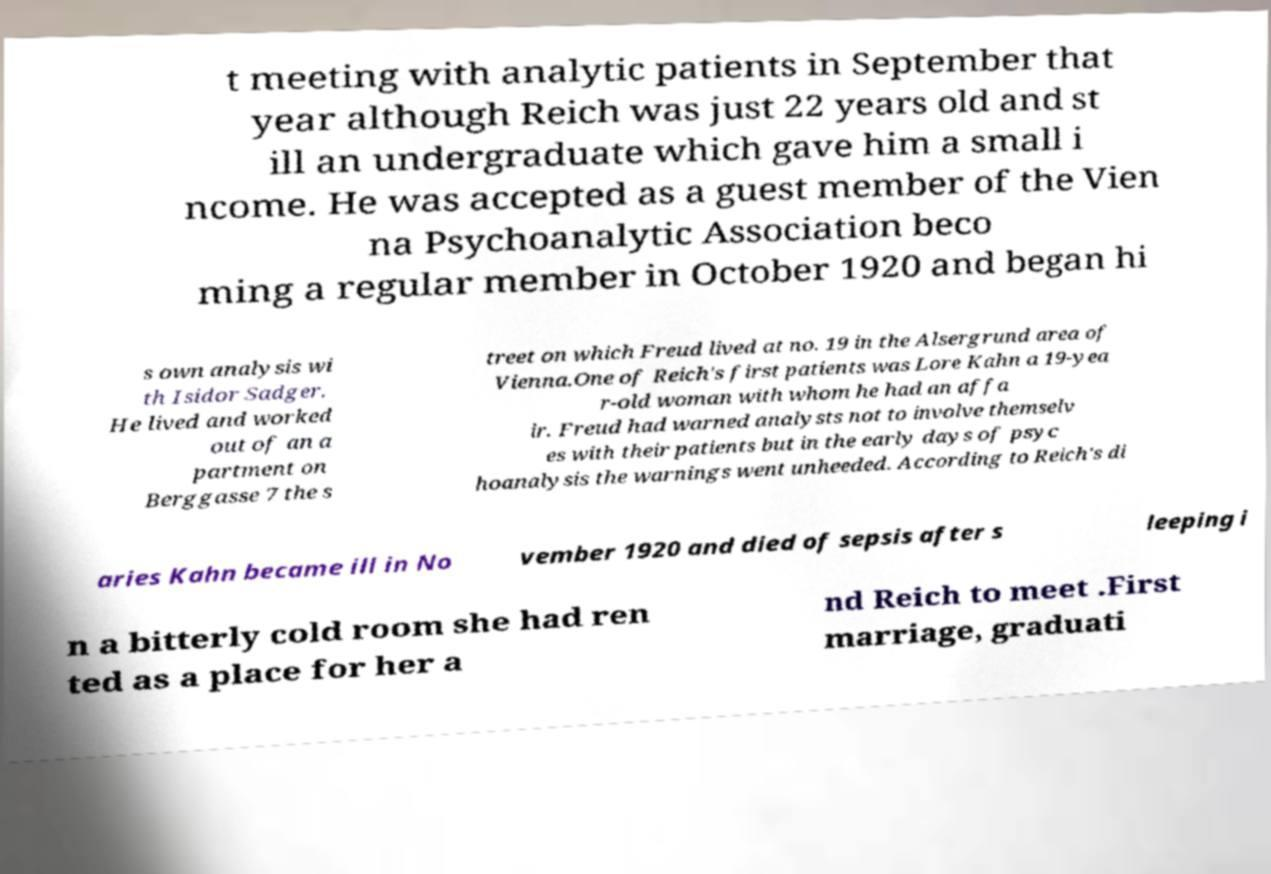Could you assist in decoding the text presented in this image and type it out clearly? t meeting with analytic patients in September that year although Reich was just 22 years old and st ill an undergraduate which gave him a small i ncome. He was accepted as a guest member of the Vien na Psychoanalytic Association beco ming a regular member in October 1920 and began hi s own analysis wi th Isidor Sadger. He lived and worked out of an a partment on Berggasse 7 the s treet on which Freud lived at no. 19 in the Alsergrund area of Vienna.One of Reich's first patients was Lore Kahn a 19-yea r-old woman with whom he had an affa ir. Freud had warned analysts not to involve themselv es with their patients but in the early days of psyc hoanalysis the warnings went unheeded. According to Reich's di aries Kahn became ill in No vember 1920 and died of sepsis after s leeping i n a bitterly cold room she had ren ted as a place for her a nd Reich to meet .First marriage, graduati 